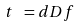<formula> <loc_0><loc_0><loc_500><loc_500>t \ = d D f</formula> 